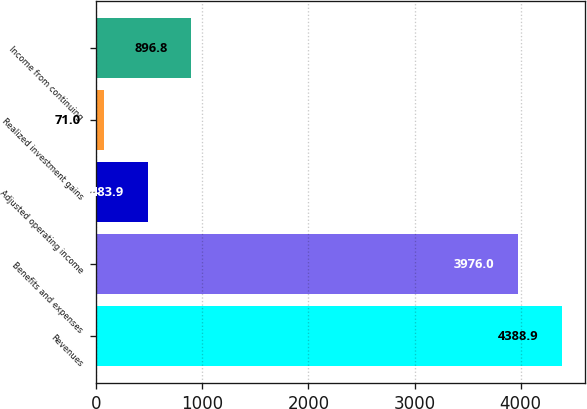<chart> <loc_0><loc_0><loc_500><loc_500><bar_chart><fcel>Revenues<fcel>Benefits and expenses<fcel>Adjusted operating income<fcel>Realized investment gains<fcel>Income from continuing<nl><fcel>4388.9<fcel>3976<fcel>483.9<fcel>71<fcel>896.8<nl></chart> 